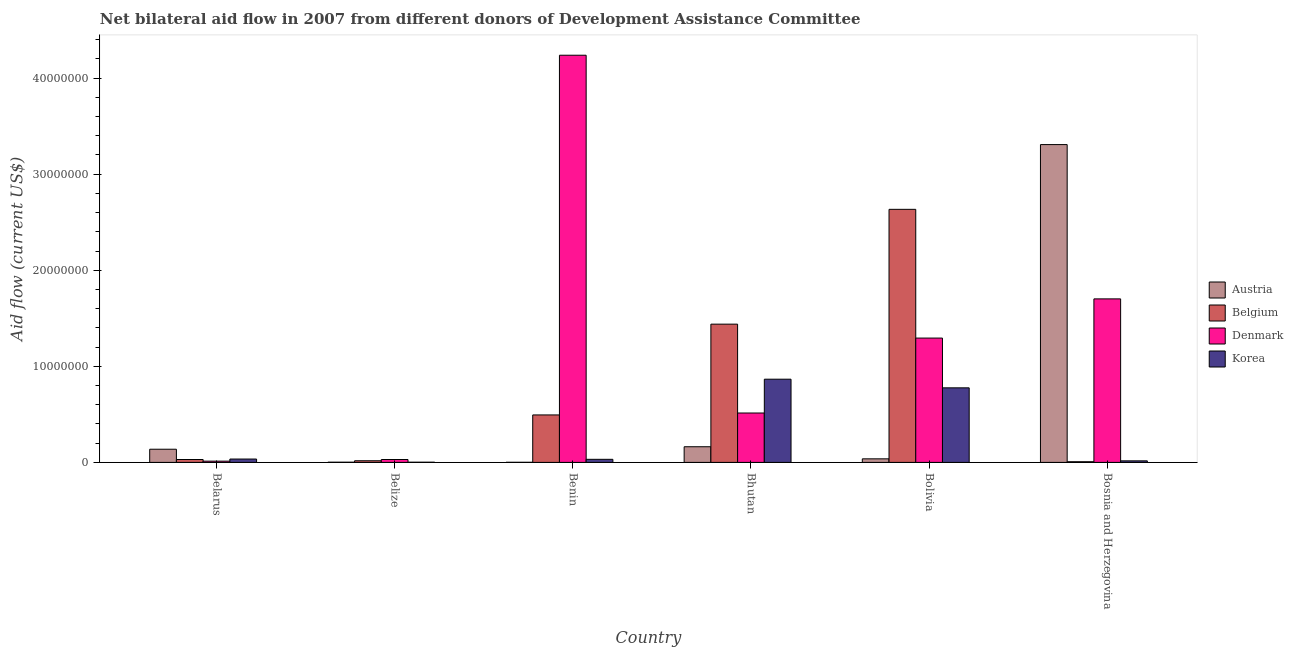How many groups of bars are there?
Give a very brief answer. 6. Are the number of bars per tick equal to the number of legend labels?
Provide a succinct answer. Yes. How many bars are there on the 2nd tick from the right?
Your answer should be compact. 4. What is the label of the 2nd group of bars from the left?
Make the answer very short. Belize. What is the amount of aid given by belgium in Bhutan?
Provide a succinct answer. 1.44e+07. Across all countries, what is the maximum amount of aid given by austria?
Give a very brief answer. 3.31e+07. Across all countries, what is the minimum amount of aid given by korea?
Keep it short and to the point. 2.00e+04. In which country was the amount of aid given by austria maximum?
Offer a terse response. Bosnia and Herzegovina. In which country was the amount of aid given by korea minimum?
Keep it short and to the point. Belize. What is the total amount of aid given by denmark in the graph?
Provide a succinct answer. 7.79e+07. What is the difference between the amount of aid given by denmark in Belarus and that in Bosnia and Herzegovina?
Offer a very short reply. -1.69e+07. What is the difference between the amount of aid given by korea in Bolivia and the amount of aid given by denmark in Belize?
Offer a very short reply. 7.46e+06. What is the average amount of aid given by denmark per country?
Provide a short and direct response. 1.30e+07. What is the difference between the amount of aid given by belgium and amount of aid given by denmark in Belize?
Provide a succinct answer. -1.30e+05. In how many countries, is the amount of aid given by denmark greater than 34000000 US$?
Offer a terse response. 1. What is the ratio of the amount of aid given by austria in Belarus to that in Benin?
Offer a terse response. 137. Is the amount of aid given by denmark in Bhutan less than that in Bolivia?
Your answer should be compact. Yes. Is the difference between the amount of aid given by korea in Belarus and Belize greater than the difference between the amount of aid given by denmark in Belarus and Belize?
Keep it short and to the point. Yes. What is the difference between the highest and the second highest amount of aid given by korea?
Offer a very short reply. 9.00e+05. What is the difference between the highest and the lowest amount of aid given by korea?
Offer a very short reply. 8.64e+06. What does the 2nd bar from the left in Belarus represents?
Make the answer very short. Belgium. What does the 1st bar from the right in Bolivia represents?
Your answer should be compact. Korea. Is it the case that in every country, the sum of the amount of aid given by austria and amount of aid given by belgium is greater than the amount of aid given by denmark?
Provide a short and direct response. No. How many bars are there?
Keep it short and to the point. 24. Are all the bars in the graph horizontal?
Offer a terse response. No. Does the graph contain grids?
Offer a very short reply. No. How many legend labels are there?
Make the answer very short. 4. What is the title of the graph?
Provide a short and direct response. Net bilateral aid flow in 2007 from different donors of Development Assistance Committee. Does "Payroll services" appear as one of the legend labels in the graph?
Make the answer very short. No. What is the label or title of the X-axis?
Make the answer very short. Country. What is the Aid flow (current US$) in Austria in Belarus?
Give a very brief answer. 1.37e+06. What is the Aid flow (current US$) of Belgium in Belarus?
Your answer should be very brief. 3.00e+05. What is the Aid flow (current US$) in Korea in Belarus?
Your answer should be compact. 3.50e+05. What is the Aid flow (current US$) of Austria in Belize?
Your answer should be compact. 2.00e+04. What is the Aid flow (current US$) of Belgium in Belize?
Your response must be concise. 1.70e+05. What is the Aid flow (current US$) in Korea in Belize?
Your answer should be compact. 2.00e+04. What is the Aid flow (current US$) in Austria in Benin?
Provide a succinct answer. 10000. What is the Aid flow (current US$) of Belgium in Benin?
Provide a succinct answer. 4.94e+06. What is the Aid flow (current US$) in Denmark in Benin?
Your answer should be compact. 4.24e+07. What is the Aid flow (current US$) in Korea in Benin?
Your answer should be compact. 3.20e+05. What is the Aid flow (current US$) of Austria in Bhutan?
Give a very brief answer. 1.63e+06. What is the Aid flow (current US$) of Belgium in Bhutan?
Make the answer very short. 1.44e+07. What is the Aid flow (current US$) in Denmark in Bhutan?
Give a very brief answer. 5.14e+06. What is the Aid flow (current US$) in Korea in Bhutan?
Provide a short and direct response. 8.66e+06. What is the Aid flow (current US$) of Belgium in Bolivia?
Your response must be concise. 2.63e+07. What is the Aid flow (current US$) in Denmark in Bolivia?
Your response must be concise. 1.29e+07. What is the Aid flow (current US$) of Korea in Bolivia?
Provide a succinct answer. 7.76e+06. What is the Aid flow (current US$) of Austria in Bosnia and Herzegovina?
Offer a very short reply. 3.31e+07. What is the Aid flow (current US$) of Denmark in Bosnia and Herzegovina?
Keep it short and to the point. 1.70e+07. What is the Aid flow (current US$) of Korea in Bosnia and Herzegovina?
Ensure brevity in your answer.  1.60e+05. Across all countries, what is the maximum Aid flow (current US$) in Austria?
Make the answer very short. 3.31e+07. Across all countries, what is the maximum Aid flow (current US$) in Belgium?
Provide a succinct answer. 2.63e+07. Across all countries, what is the maximum Aid flow (current US$) in Denmark?
Your answer should be very brief. 4.24e+07. Across all countries, what is the maximum Aid flow (current US$) of Korea?
Offer a very short reply. 8.66e+06. Across all countries, what is the minimum Aid flow (current US$) in Korea?
Your answer should be very brief. 2.00e+04. What is the total Aid flow (current US$) in Austria in the graph?
Keep it short and to the point. 3.65e+07. What is the total Aid flow (current US$) of Belgium in the graph?
Give a very brief answer. 4.62e+07. What is the total Aid flow (current US$) of Denmark in the graph?
Provide a succinct answer. 7.79e+07. What is the total Aid flow (current US$) of Korea in the graph?
Make the answer very short. 1.73e+07. What is the difference between the Aid flow (current US$) of Austria in Belarus and that in Belize?
Your answer should be very brief. 1.35e+06. What is the difference between the Aid flow (current US$) of Korea in Belarus and that in Belize?
Ensure brevity in your answer.  3.30e+05. What is the difference between the Aid flow (current US$) in Austria in Belarus and that in Benin?
Make the answer very short. 1.36e+06. What is the difference between the Aid flow (current US$) of Belgium in Belarus and that in Benin?
Your response must be concise. -4.64e+06. What is the difference between the Aid flow (current US$) of Denmark in Belarus and that in Benin?
Offer a terse response. -4.22e+07. What is the difference between the Aid flow (current US$) in Austria in Belarus and that in Bhutan?
Offer a terse response. -2.60e+05. What is the difference between the Aid flow (current US$) of Belgium in Belarus and that in Bhutan?
Ensure brevity in your answer.  -1.41e+07. What is the difference between the Aid flow (current US$) of Denmark in Belarus and that in Bhutan?
Offer a very short reply. -5.01e+06. What is the difference between the Aid flow (current US$) in Korea in Belarus and that in Bhutan?
Ensure brevity in your answer.  -8.31e+06. What is the difference between the Aid flow (current US$) in Austria in Belarus and that in Bolivia?
Your response must be concise. 1.00e+06. What is the difference between the Aid flow (current US$) of Belgium in Belarus and that in Bolivia?
Provide a succinct answer. -2.60e+07. What is the difference between the Aid flow (current US$) in Denmark in Belarus and that in Bolivia?
Your answer should be very brief. -1.28e+07. What is the difference between the Aid flow (current US$) in Korea in Belarus and that in Bolivia?
Provide a short and direct response. -7.41e+06. What is the difference between the Aid flow (current US$) of Austria in Belarus and that in Bosnia and Herzegovina?
Keep it short and to the point. -3.17e+07. What is the difference between the Aid flow (current US$) of Denmark in Belarus and that in Bosnia and Herzegovina?
Make the answer very short. -1.69e+07. What is the difference between the Aid flow (current US$) in Korea in Belarus and that in Bosnia and Herzegovina?
Your answer should be very brief. 1.90e+05. What is the difference between the Aid flow (current US$) of Austria in Belize and that in Benin?
Make the answer very short. 10000. What is the difference between the Aid flow (current US$) in Belgium in Belize and that in Benin?
Your response must be concise. -4.77e+06. What is the difference between the Aid flow (current US$) of Denmark in Belize and that in Benin?
Your response must be concise. -4.21e+07. What is the difference between the Aid flow (current US$) of Korea in Belize and that in Benin?
Make the answer very short. -3.00e+05. What is the difference between the Aid flow (current US$) in Austria in Belize and that in Bhutan?
Your answer should be very brief. -1.61e+06. What is the difference between the Aid flow (current US$) of Belgium in Belize and that in Bhutan?
Your answer should be very brief. -1.42e+07. What is the difference between the Aid flow (current US$) in Denmark in Belize and that in Bhutan?
Offer a very short reply. -4.84e+06. What is the difference between the Aid flow (current US$) of Korea in Belize and that in Bhutan?
Your answer should be compact. -8.64e+06. What is the difference between the Aid flow (current US$) in Austria in Belize and that in Bolivia?
Give a very brief answer. -3.50e+05. What is the difference between the Aid flow (current US$) in Belgium in Belize and that in Bolivia?
Your answer should be compact. -2.62e+07. What is the difference between the Aid flow (current US$) in Denmark in Belize and that in Bolivia?
Make the answer very short. -1.26e+07. What is the difference between the Aid flow (current US$) in Korea in Belize and that in Bolivia?
Keep it short and to the point. -7.74e+06. What is the difference between the Aid flow (current US$) of Austria in Belize and that in Bosnia and Herzegovina?
Give a very brief answer. -3.31e+07. What is the difference between the Aid flow (current US$) of Denmark in Belize and that in Bosnia and Herzegovina?
Your answer should be very brief. -1.67e+07. What is the difference between the Aid flow (current US$) of Austria in Benin and that in Bhutan?
Give a very brief answer. -1.62e+06. What is the difference between the Aid flow (current US$) in Belgium in Benin and that in Bhutan?
Provide a succinct answer. -9.45e+06. What is the difference between the Aid flow (current US$) of Denmark in Benin and that in Bhutan?
Make the answer very short. 3.72e+07. What is the difference between the Aid flow (current US$) in Korea in Benin and that in Bhutan?
Provide a succinct answer. -8.34e+06. What is the difference between the Aid flow (current US$) of Austria in Benin and that in Bolivia?
Keep it short and to the point. -3.60e+05. What is the difference between the Aid flow (current US$) in Belgium in Benin and that in Bolivia?
Provide a succinct answer. -2.14e+07. What is the difference between the Aid flow (current US$) of Denmark in Benin and that in Bolivia?
Your response must be concise. 2.94e+07. What is the difference between the Aid flow (current US$) in Korea in Benin and that in Bolivia?
Your answer should be compact. -7.44e+06. What is the difference between the Aid flow (current US$) of Austria in Benin and that in Bosnia and Herzegovina?
Give a very brief answer. -3.31e+07. What is the difference between the Aid flow (current US$) of Belgium in Benin and that in Bosnia and Herzegovina?
Keep it short and to the point. 4.87e+06. What is the difference between the Aid flow (current US$) in Denmark in Benin and that in Bosnia and Herzegovina?
Give a very brief answer. 2.54e+07. What is the difference between the Aid flow (current US$) in Austria in Bhutan and that in Bolivia?
Ensure brevity in your answer.  1.26e+06. What is the difference between the Aid flow (current US$) in Belgium in Bhutan and that in Bolivia?
Provide a short and direct response. -1.20e+07. What is the difference between the Aid flow (current US$) of Denmark in Bhutan and that in Bolivia?
Offer a terse response. -7.80e+06. What is the difference between the Aid flow (current US$) of Austria in Bhutan and that in Bosnia and Herzegovina?
Your response must be concise. -3.14e+07. What is the difference between the Aid flow (current US$) of Belgium in Bhutan and that in Bosnia and Herzegovina?
Your response must be concise. 1.43e+07. What is the difference between the Aid flow (current US$) of Denmark in Bhutan and that in Bosnia and Herzegovina?
Provide a succinct answer. -1.19e+07. What is the difference between the Aid flow (current US$) of Korea in Bhutan and that in Bosnia and Herzegovina?
Your answer should be compact. 8.50e+06. What is the difference between the Aid flow (current US$) of Austria in Bolivia and that in Bosnia and Herzegovina?
Offer a terse response. -3.27e+07. What is the difference between the Aid flow (current US$) of Belgium in Bolivia and that in Bosnia and Herzegovina?
Offer a terse response. 2.63e+07. What is the difference between the Aid flow (current US$) in Denmark in Bolivia and that in Bosnia and Herzegovina?
Your answer should be compact. -4.08e+06. What is the difference between the Aid flow (current US$) of Korea in Bolivia and that in Bosnia and Herzegovina?
Provide a succinct answer. 7.60e+06. What is the difference between the Aid flow (current US$) of Austria in Belarus and the Aid flow (current US$) of Belgium in Belize?
Ensure brevity in your answer.  1.20e+06. What is the difference between the Aid flow (current US$) in Austria in Belarus and the Aid flow (current US$) in Denmark in Belize?
Ensure brevity in your answer.  1.07e+06. What is the difference between the Aid flow (current US$) in Austria in Belarus and the Aid flow (current US$) in Korea in Belize?
Keep it short and to the point. 1.35e+06. What is the difference between the Aid flow (current US$) of Belgium in Belarus and the Aid flow (current US$) of Denmark in Belize?
Your response must be concise. 0. What is the difference between the Aid flow (current US$) in Belgium in Belarus and the Aid flow (current US$) in Korea in Belize?
Offer a terse response. 2.80e+05. What is the difference between the Aid flow (current US$) of Austria in Belarus and the Aid flow (current US$) of Belgium in Benin?
Your answer should be compact. -3.57e+06. What is the difference between the Aid flow (current US$) of Austria in Belarus and the Aid flow (current US$) of Denmark in Benin?
Ensure brevity in your answer.  -4.10e+07. What is the difference between the Aid flow (current US$) of Austria in Belarus and the Aid flow (current US$) of Korea in Benin?
Give a very brief answer. 1.05e+06. What is the difference between the Aid flow (current US$) of Belgium in Belarus and the Aid flow (current US$) of Denmark in Benin?
Ensure brevity in your answer.  -4.21e+07. What is the difference between the Aid flow (current US$) of Belgium in Belarus and the Aid flow (current US$) of Korea in Benin?
Keep it short and to the point. -2.00e+04. What is the difference between the Aid flow (current US$) in Austria in Belarus and the Aid flow (current US$) in Belgium in Bhutan?
Provide a succinct answer. -1.30e+07. What is the difference between the Aid flow (current US$) of Austria in Belarus and the Aid flow (current US$) of Denmark in Bhutan?
Offer a terse response. -3.77e+06. What is the difference between the Aid flow (current US$) in Austria in Belarus and the Aid flow (current US$) in Korea in Bhutan?
Make the answer very short. -7.29e+06. What is the difference between the Aid flow (current US$) in Belgium in Belarus and the Aid flow (current US$) in Denmark in Bhutan?
Offer a terse response. -4.84e+06. What is the difference between the Aid flow (current US$) in Belgium in Belarus and the Aid flow (current US$) in Korea in Bhutan?
Make the answer very short. -8.36e+06. What is the difference between the Aid flow (current US$) in Denmark in Belarus and the Aid flow (current US$) in Korea in Bhutan?
Keep it short and to the point. -8.53e+06. What is the difference between the Aid flow (current US$) in Austria in Belarus and the Aid flow (current US$) in Belgium in Bolivia?
Keep it short and to the point. -2.50e+07. What is the difference between the Aid flow (current US$) of Austria in Belarus and the Aid flow (current US$) of Denmark in Bolivia?
Provide a succinct answer. -1.16e+07. What is the difference between the Aid flow (current US$) in Austria in Belarus and the Aid flow (current US$) in Korea in Bolivia?
Provide a short and direct response. -6.39e+06. What is the difference between the Aid flow (current US$) in Belgium in Belarus and the Aid flow (current US$) in Denmark in Bolivia?
Provide a short and direct response. -1.26e+07. What is the difference between the Aid flow (current US$) in Belgium in Belarus and the Aid flow (current US$) in Korea in Bolivia?
Offer a very short reply. -7.46e+06. What is the difference between the Aid flow (current US$) in Denmark in Belarus and the Aid flow (current US$) in Korea in Bolivia?
Keep it short and to the point. -7.63e+06. What is the difference between the Aid flow (current US$) in Austria in Belarus and the Aid flow (current US$) in Belgium in Bosnia and Herzegovina?
Provide a short and direct response. 1.30e+06. What is the difference between the Aid flow (current US$) in Austria in Belarus and the Aid flow (current US$) in Denmark in Bosnia and Herzegovina?
Provide a short and direct response. -1.56e+07. What is the difference between the Aid flow (current US$) of Austria in Belarus and the Aid flow (current US$) of Korea in Bosnia and Herzegovina?
Provide a succinct answer. 1.21e+06. What is the difference between the Aid flow (current US$) of Belgium in Belarus and the Aid flow (current US$) of Denmark in Bosnia and Herzegovina?
Provide a succinct answer. -1.67e+07. What is the difference between the Aid flow (current US$) of Belgium in Belarus and the Aid flow (current US$) of Korea in Bosnia and Herzegovina?
Provide a succinct answer. 1.40e+05. What is the difference between the Aid flow (current US$) of Denmark in Belarus and the Aid flow (current US$) of Korea in Bosnia and Herzegovina?
Offer a terse response. -3.00e+04. What is the difference between the Aid flow (current US$) in Austria in Belize and the Aid flow (current US$) in Belgium in Benin?
Offer a very short reply. -4.92e+06. What is the difference between the Aid flow (current US$) in Austria in Belize and the Aid flow (current US$) in Denmark in Benin?
Your response must be concise. -4.24e+07. What is the difference between the Aid flow (current US$) in Belgium in Belize and the Aid flow (current US$) in Denmark in Benin?
Make the answer very short. -4.22e+07. What is the difference between the Aid flow (current US$) of Belgium in Belize and the Aid flow (current US$) of Korea in Benin?
Ensure brevity in your answer.  -1.50e+05. What is the difference between the Aid flow (current US$) in Austria in Belize and the Aid flow (current US$) in Belgium in Bhutan?
Ensure brevity in your answer.  -1.44e+07. What is the difference between the Aid flow (current US$) of Austria in Belize and the Aid flow (current US$) of Denmark in Bhutan?
Your answer should be compact. -5.12e+06. What is the difference between the Aid flow (current US$) of Austria in Belize and the Aid flow (current US$) of Korea in Bhutan?
Give a very brief answer. -8.64e+06. What is the difference between the Aid flow (current US$) in Belgium in Belize and the Aid flow (current US$) in Denmark in Bhutan?
Your response must be concise. -4.97e+06. What is the difference between the Aid flow (current US$) in Belgium in Belize and the Aid flow (current US$) in Korea in Bhutan?
Your response must be concise. -8.49e+06. What is the difference between the Aid flow (current US$) in Denmark in Belize and the Aid flow (current US$) in Korea in Bhutan?
Give a very brief answer. -8.36e+06. What is the difference between the Aid flow (current US$) of Austria in Belize and the Aid flow (current US$) of Belgium in Bolivia?
Make the answer very short. -2.63e+07. What is the difference between the Aid flow (current US$) of Austria in Belize and the Aid flow (current US$) of Denmark in Bolivia?
Ensure brevity in your answer.  -1.29e+07. What is the difference between the Aid flow (current US$) in Austria in Belize and the Aid flow (current US$) in Korea in Bolivia?
Ensure brevity in your answer.  -7.74e+06. What is the difference between the Aid flow (current US$) in Belgium in Belize and the Aid flow (current US$) in Denmark in Bolivia?
Offer a very short reply. -1.28e+07. What is the difference between the Aid flow (current US$) in Belgium in Belize and the Aid flow (current US$) in Korea in Bolivia?
Make the answer very short. -7.59e+06. What is the difference between the Aid flow (current US$) of Denmark in Belize and the Aid flow (current US$) of Korea in Bolivia?
Make the answer very short. -7.46e+06. What is the difference between the Aid flow (current US$) in Austria in Belize and the Aid flow (current US$) in Belgium in Bosnia and Herzegovina?
Provide a succinct answer. -5.00e+04. What is the difference between the Aid flow (current US$) of Austria in Belize and the Aid flow (current US$) of Denmark in Bosnia and Herzegovina?
Your response must be concise. -1.70e+07. What is the difference between the Aid flow (current US$) in Belgium in Belize and the Aid flow (current US$) in Denmark in Bosnia and Herzegovina?
Your answer should be compact. -1.68e+07. What is the difference between the Aid flow (current US$) in Denmark in Belize and the Aid flow (current US$) in Korea in Bosnia and Herzegovina?
Keep it short and to the point. 1.40e+05. What is the difference between the Aid flow (current US$) of Austria in Benin and the Aid flow (current US$) of Belgium in Bhutan?
Ensure brevity in your answer.  -1.44e+07. What is the difference between the Aid flow (current US$) of Austria in Benin and the Aid flow (current US$) of Denmark in Bhutan?
Keep it short and to the point. -5.13e+06. What is the difference between the Aid flow (current US$) of Austria in Benin and the Aid flow (current US$) of Korea in Bhutan?
Your answer should be compact. -8.65e+06. What is the difference between the Aid flow (current US$) in Belgium in Benin and the Aid flow (current US$) in Denmark in Bhutan?
Your answer should be very brief. -2.00e+05. What is the difference between the Aid flow (current US$) in Belgium in Benin and the Aid flow (current US$) in Korea in Bhutan?
Your answer should be compact. -3.72e+06. What is the difference between the Aid flow (current US$) of Denmark in Benin and the Aid flow (current US$) of Korea in Bhutan?
Your answer should be compact. 3.37e+07. What is the difference between the Aid flow (current US$) in Austria in Benin and the Aid flow (current US$) in Belgium in Bolivia?
Offer a very short reply. -2.63e+07. What is the difference between the Aid flow (current US$) in Austria in Benin and the Aid flow (current US$) in Denmark in Bolivia?
Offer a very short reply. -1.29e+07. What is the difference between the Aid flow (current US$) of Austria in Benin and the Aid flow (current US$) of Korea in Bolivia?
Ensure brevity in your answer.  -7.75e+06. What is the difference between the Aid flow (current US$) of Belgium in Benin and the Aid flow (current US$) of Denmark in Bolivia?
Offer a very short reply. -8.00e+06. What is the difference between the Aid flow (current US$) in Belgium in Benin and the Aid flow (current US$) in Korea in Bolivia?
Your answer should be very brief. -2.82e+06. What is the difference between the Aid flow (current US$) in Denmark in Benin and the Aid flow (current US$) in Korea in Bolivia?
Give a very brief answer. 3.46e+07. What is the difference between the Aid flow (current US$) of Austria in Benin and the Aid flow (current US$) of Belgium in Bosnia and Herzegovina?
Keep it short and to the point. -6.00e+04. What is the difference between the Aid flow (current US$) in Austria in Benin and the Aid flow (current US$) in Denmark in Bosnia and Herzegovina?
Your answer should be compact. -1.70e+07. What is the difference between the Aid flow (current US$) in Austria in Benin and the Aid flow (current US$) in Korea in Bosnia and Herzegovina?
Give a very brief answer. -1.50e+05. What is the difference between the Aid flow (current US$) of Belgium in Benin and the Aid flow (current US$) of Denmark in Bosnia and Herzegovina?
Give a very brief answer. -1.21e+07. What is the difference between the Aid flow (current US$) of Belgium in Benin and the Aid flow (current US$) of Korea in Bosnia and Herzegovina?
Your answer should be very brief. 4.78e+06. What is the difference between the Aid flow (current US$) of Denmark in Benin and the Aid flow (current US$) of Korea in Bosnia and Herzegovina?
Make the answer very short. 4.22e+07. What is the difference between the Aid flow (current US$) in Austria in Bhutan and the Aid flow (current US$) in Belgium in Bolivia?
Provide a succinct answer. -2.47e+07. What is the difference between the Aid flow (current US$) in Austria in Bhutan and the Aid flow (current US$) in Denmark in Bolivia?
Your answer should be very brief. -1.13e+07. What is the difference between the Aid flow (current US$) of Austria in Bhutan and the Aid flow (current US$) of Korea in Bolivia?
Ensure brevity in your answer.  -6.13e+06. What is the difference between the Aid flow (current US$) in Belgium in Bhutan and the Aid flow (current US$) in Denmark in Bolivia?
Offer a very short reply. 1.45e+06. What is the difference between the Aid flow (current US$) of Belgium in Bhutan and the Aid flow (current US$) of Korea in Bolivia?
Give a very brief answer. 6.63e+06. What is the difference between the Aid flow (current US$) of Denmark in Bhutan and the Aid flow (current US$) of Korea in Bolivia?
Offer a terse response. -2.62e+06. What is the difference between the Aid flow (current US$) in Austria in Bhutan and the Aid flow (current US$) in Belgium in Bosnia and Herzegovina?
Provide a succinct answer. 1.56e+06. What is the difference between the Aid flow (current US$) of Austria in Bhutan and the Aid flow (current US$) of Denmark in Bosnia and Herzegovina?
Provide a short and direct response. -1.54e+07. What is the difference between the Aid flow (current US$) in Austria in Bhutan and the Aid flow (current US$) in Korea in Bosnia and Herzegovina?
Offer a very short reply. 1.47e+06. What is the difference between the Aid flow (current US$) in Belgium in Bhutan and the Aid flow (current US$) in Denmark in Bosnia and Herzegovina?
Give a very brief answer. -2.63e+06. What is the difference between the Aid flow (current US$) in Belgium in Bhutan and the Aid flow (current US$) in Korea in Bosnia and Herzegovina?
Provide a succinct answer. 1.42e+07. What is the difference between the Aid flow (current US$) of Denmark in Bhutan and the Aid flow (current US$) of Korea in Bosnia and Herzegovina?
Offer a very short reply. 4.98e+06. What is the difference between the Aid flow (current US$) of Austria in Bolivia and the Aid flow (current US$) of Belgium in Bosnia and Herzegovina?
Your answer should be very brief. 3.00e+05. What is the difference between the Aid flow (current US$) in Austria in Bolivia and the Aid flow (current US$) in Denmark in Bosnia and Herzegovina?
Provide a short and direct response. -1.66e+07. What is the difference between the Aid flow (current US$) in Belgium in Bolivia and the Aid flow (current US$) in Denmark in Bosnia and Herzegovina?
Provide a succinct answer. 9.32e+06. What is the difference between the Aid flow (current US$) of Belgium in Bolivia and the Aid flow (current US$) of Korea in Bosnia and Herzegovina?
Make the answer very short. 2.62e+07. What is the difference between the Aid flow (current US$) in Denmark in Bolivia and the Aid flow (current US$) in Korea in Bosnia and Herzegovina?
Keep it short and to the point. 1.28e+07. What is the average Aid flow (current US$) in Austria per country?
Give a very brief answer. 6.08e+06. What is the average Aid flow (current US$) of Belgium per country?
Your answer should be compact. 7.70e+06. What is the average Aid flow (current US$) in Denmark per country?
Provide a short and direct response. 1.30e+07. What is the average Aid flow (current US$) in Korea per country?
Provide a succinct answer. 2.88e+06. What is the difference between the Aid flow (current US$) in Austria and Aid flow (current US$) in Belgium in Belarus?
Give a very brief answer. 1.07e+06. What is the difference between the Aid flow (current US$) of Austria and Aid flow (current US$) of Denmark in Belarus?
Provide a succinct answer. 1.24e+06. What is the difference between the Aid flow (current US$) in Austria and Aid flow (current US$) in Korea in Belarus?
Give a very brief answer. 1.02e+06. What is the difference between the Aid flow (current US$) of Belgium and Aid flow (current US$) of Denmark in Belarus?
Keep it short and to the point. 1.70e+05. What is the difference between the Aid flow (current US$) of Austria and Aid flow (current US$) of Belgium in Belize?
Offer a terse response. -1.50e+05. What is the difference between the Aid flow (current US$) of Austria and Aid flow (current US$) of Denmark in Belize?
Provide a short and direct response. -2.80e+05. What is the difference between the Aid flow (current US$) of Austria and Aid flow (current US$) of Korea in Belize?
Provide a succinct answer. 0. What is the difference between the Aid flow (current US$) in Belgium and Aid flow (current US$) in Denmark in Belize?
Offer a very short reply. -1.30e+05. What is the difference between the Aid flow (current US$) of Belgium and Aid flow (current US$) of Korea in Belize?
Offer a terse response. 1.50e+05. What is the difference between the Aid flow (current US$) of Austria and Aid flow (current US$) of Belgium in Benin?
Your response must be concise. -4.93e+06. What is the difference between the Aid flow (current US$) of Austria and Aid flow (current US$) of Denmark in Benin?
Give a very brief answer. -4.24e+07. What is the difference between the Aid flow (current US$) in Austria and Aid flow (current US$) in Korea in Benin?
Your answer should be very brief. -3.10e+05. What is the difference between the Aid flow (current US$) of Belgium and Aid flow (current US$) of Denmark in Benin?
Make the answer very short. -3.74e+07. What is the difference between the Aid flow (current US$) of Belgium and Aid flow (current US$) of Korea in Benin?
Provide a short and direct response. 4.62e+06. What is the difference between the Aid flow (current US$) of Denmark and Aid flow (current US$) of Korea in Benin?
Offer a very short reply. 4.21e+07. What is the difference between the Aid flow (current US$) of Austria and Aid flow (current US$) of Belgium in Bhutan?
Your answer should be very brief. -1.28e+07. What is the difference between the Aid flow (current US$) in Austria and Aid flow (current US$) in Denmark in Bhutan?
Keep it short and to the point. -3.51e+06. What is the difference between the Aid flow (current US$) of Austria and Aid flow (current US$) of Korea in Bhutan?
Offer a terse response. -7.03e+06. What is the difference between the Aid flow (current US$) in Belgium and Aid flow (current US$) in Denmark in Bhutan?
Make the answer very short. 9.25e+06. What is the difference between the Aid flow (current US$) in Belgium and Aid flow (current US$) in Korea in Bhutan?
Keep it short and to the point. 5.73e+06. What is the difference between the Aid flow (current US$) of Denmark and Aid flow (current US$) of Korea in Bhutan?
Offer a terse response. -3.52e+06. What is the difference between the Aid flow (current US$) of Austria and Aid flow (current US$) of Belgium in Bolivia?
Keep it short and to the point. -2.60e+07. What is the difference between the Aid flow (current US$) of Austria and Aid flow (current US$) of Denmark in Bolivia?
Provide a succinct answer. -1.26e+07. What is the difference between the Aid flow (current US$) in Austria and Aid flow (current US$) in Korea in Bolivia?
Provide a short and direct response. -7.39e+06. What is the difference between the Aid flow (current US$) of Belgium and Aid flow (current US$) of Denmark in Bolivia?
Give a very brief answer. 1.34e+07. What is the difference between the Aid flow (current US$) of Belgium and Aid flow (current US$) of Korea in Bolivia?
Offer a terse response. 1.86e+07. What is the difference between the Aid flow (current US$) of Denmark and Aid flow (current US$) of Korea in Bolivia?
Keep it short and to the point. 5.18e+06. What is the difference between the Aid flow (current US$) of Austria and Aid flow (current US$) of Belgium in Bosnia and Herzegovina?
Provide a short and direct response. 3.30e+07. What is the difference between the Aid flow (current US$) of Austria and Aid flow (current US$) of Denmark in Bosnia and Herzegovina?
Keep it short and to the point. 1.61e+07. What is the difference between the Aid flow (current US$) in Austria and Aid flow (current US$) in Korea in Bosnia and Herzegovina?
Offer a terse response. 3.29e+07. What is the difference between the Aid flow (current US$) in Belgium and Aid flow (current US$) in Denmark in Bosnia and Herzegovina?
Ensure brevity in your answer.  -1.70e+07. What is the difference between the Aid flow (current US$) in Denmark and Aid flow (current US$) in Korea in Bosnia and Herzegovina?
Offer a very short reply. 1.69e+07. What is the ratio of the Aid flow (current US$) of Austria in Belarus to that in Belize?
Offer a very short reply. 68.5. What is the ratio of the Aid flow (current US$) of Belgium in Belarus to that in Belize?
Provide a short and direct response. 1.76. What is the ratio of the Aid flow (current US$) of Denmark in Belarus to that in Belize?
Provide a succinct answer. 0.43. What is the ratio of the Aid flow (current US$) of Korea in Belarus to that in Belize?
Offer a terse response. 17.5. What is the ratio of the Aid flow (current US$) in Austria in Belarus to that in Benin?
Ensure brevity in your answer.  137. What is the ratio of the Aid flow (current US$) in Belgium in Belarus to that in Benin?
Give a very brief answer. 0.06. What is the ratio of the Aid flow (current US$) of Denmark in Belarus to that in Benin?
Make the answer very short. 0. What is the ratio of the Aid flow (current US$) of Korea in Belarus to that in Benin?
Give a very brief answer. 1.09. What is the ratio of the Aid flow (current US$) in Austria in Belarus to that in Bhutan?
Give a very brief answer. 0.84. What is the ratio of the Aid flow (current US$) of Belgium in Belarus to that in Bhutan?
Give a very brief answer. 0.02. What is the ratio of the Aid flow (current US$) in Denmark in Belarus to that in Bhutan?
Your response must be concise. 0.03. What is the ratio of the Aid flow (current US$) of Korea in Belarus to that in Bhutan?
Give a very brief answer. 0.04. What is the ratio of the Aid flow (current US$) in Austria in Belarus to that in Bolivia?
Provide a succinct answer. 3.7. What is the ratio of the Aid flow (current US$) of Belgium in Belarus to that in Bolivia?
Provide a short and direct response. 0.01. What is the ratio of the Aid flow (current US$) in Denmark in Belarus to that in Bolivia?
Give a very brief answer. 0.01. What is the ratio of the Aid flow (current US$) of Korea in Belarus to that in Bolivia?
Offer a very short reply. 0.05. What is the ratio of the Aid flow (current US$) of Austria in Belarus to that in Bosnia and Herzegovina?
Ensure brevity in your answer.  0.04. What is the ratio of the Aid flow (current US$) of Belgium in Belarus to that in Bosnia and Herzegovina?
Your answer should be very brief. 4.29. What is the ratio of the Aid flow (current US$) in Denmark in Belarus to that in Bosnia and Herzegovina?
Ensure brevity in your answer.  0.01. What is the ratio of the Aid flow (current US$) of Korea in Belarus to that in Bosnia and Herzegovina?
Your answer should be very brief. 2.19. What is the ratio of the Aid flow (current US$) of Austria in Belize to that in Benin?
Provide a short and direct response. 2. What is the ratio of the Aid flow (current US$) of Belgium in Belize to that in Benin?
Your answer should be very brief. 0.03. What is the ratio of the Aid flow (current US$) of Denmark in Belize to that in Benin?
Offer a very short reply. 0.01. What is the ratio of the Aid flow (current US$) of Korea in Belize to that in Benin?
Provide a succinct answer. 0.06. What is the ratio of the Aid flow (current US$) in Austria in Belize to that in Bhutan?
Provide a succinct answer. 0.01. What is the ratio of the Aid flow (current US$) of Belgium in Belize to that in Bhutan?
Keep it short and to the point. 0.01. What is the ratio of the Aid flow (current US$) of Denmark in Belize to that in Bhutan?
Offer a very short reply. 0.06. What is the ratio of the Aid flow (current US$) in Korea in Belize to that in Bhutan?
Your answer should be very brief. 0. What is the ratio of the Aid flow (current US$) in Austria in Belize to that in Bolivia?
Make the answer very short. 0.05. What is the ratio of the Aid flow (current US$) of Belgium in Belize to that in Bolivia?
Offer a very short reply. 0.01. What is the ratio of the Aid flow (current US$) of Denmark in Belize to that in Bolivia?
Offer a very short reply. 0.02. What is the ratio of the Aid flow (current US$) of Korea in Belize to that in Bolivia?
Provide a succinct answer. 0. What is the ratio of the Aid flow (current US$) of Austria in Belize to that in Bosnia and Herzegovina?
Give a very brief answer. 0. What is the ratio of the Aid flow (current US$) in Belgium in Belize to that in Bosnia and Herzegovina?
Offer a terse response. 2.43. What is the ratio of the Aid flow (current US$) of Denmark in Belize to that in Bosnia and Herzegovina?
Make the answer very short. 0.02. What is the ratio of the Aid flow (current US$) of Korea in Belize to that in Bosnia and Herzegovina?
Your response must be concise. 0.12. What is the ratio of the Aid flow (current US$) in Austria in Benin to that in Bhutan?
Provide a succinct answer. 0.01. What is the ratio of the Aid flow (current US$) in Belgium in Benin to that in Bhutan?
Give a very brief answer. 0.34. What is the ratio of the Aid flow (current US$) in Denmark in Benin to that in Bhutan?
Offer a very short reply. 8.25. What is the ratio of the Aid flow (current US$) of Korea in Benin to that in Bhutan?
Your answer should be very brief. 0.04. What is the ratio of the Aid flow (current US$) of Austria in Benin to that in Bolivia?
Give a very brief answer. 0.03. What is the ratio of the Aid flow (current US$) in Belgium in Benin to that in Bolivia?
Ensure brevity in your answer.  0.19. What is the ratio of the Aid flow (current US$) of Denmark in Benin to that in Bolivia?
Your response must be concise. 3.28. What is the ratio of the Aid flow (current US$) in Korea in Benin to that in Bolivia?
Your answer should be compact. 0.04. What is the ratio of the Aid flow (current US$) of Austria in Benin to that in Bosnia and Herzegovina?
Your answer should be very brief. 0. What is the ratio of the Aid flow (current US$) of Belgium in Benin to that in Bosnia and Herzegovina?
Give a very brief answer. 70.57. What is the ratio of the Aid flow (current US$) in Denmark in Benin to that in Bosnia and Herzegovina?
Ensure brevity in your answer.  2.49. What is the ratio of the Aid flow (current US$) of Korea in Benin to that in Bosnia and Herzegovina?
Offer a terse response. 2. What is the ratio of the Aid flow (current US$) in Austria in Bhutan to that in Bolivia?
Your answer should be very brief. 4.41. What is the ratio of the Aid flow (current US$) in Belgium in Bhutan to that in Bolivia?
Ensure brevity in your answer.  0.55. What is the ratio of the Aid flow (current US$) of Denmark in Bhutan to that in Bolivia?
Your response must be concise. 0.4. What is the ratio of the Aid flow (current US$) of Korea in Bhutan to that in Bolivia?
Ensure brevity in your answer.  1.12. What is the ratio of the Aid flow (current US$) of Austria in Bhutan to that in Bosnia and Herzegovina?
Offer a terse response. 0.05. What is the ratio of the Aid flow (current US$) of Belgium in Bhutan to that in Bosnia and Herzegovina?
Keep it short and to the point. 205.57. What is the ratio of the Aid flow (current US$) in Denmark in Bhutan to that in Bosnia and Herzegovina?
Offer a very short reply. 0.3. What is the ratio of the Aid flow (current US$) in Korea in Bhutan to that in Bosnia and Herzegovina?
Provide a succinct answer. 54.12. What is the ratio of the Aid flow (current US$) of Austria in Bolivia to that in Bosnia and Herzegovina?
Provide a short and direct response. 0.01. What is the ratio of the Aid flow (current US$) in Belgium in Bolivia to that in Bosnia and Herzegovina?
Give a very brief answer. 376.29. What is the ratio of the Aid flow (current US$) in Denmark in Bolivia to that in Bosnia and Herzegovina?
Ensure brevity in your answer.  0.76. What is the ratio of the Aid flow (current US$) of Korea in Bolivia to that in Bosnia and Herzegovina?
Provide a short and direct response. 48.5. What is the difference between the highest and the second highest Aid flow (current US$) in Austria?
Give a very brief answer. 3.14e+07. What is the difference between the highest and the second highest Aid flow (current US$) in Belgium?
Your answer should be compact. 1.20e+07. What is the difference between the highest and the second highest Aid flow (current US$) in Denmark?
Ensure brevity in your answer.  2.54e+07. What is the difference between the highest and the lowest Aid flow (current US$) in Austria?
Your answer should be very brief. 3.31e+07. What is the difference between the highest and the lowest Aid flow (current US$) of Belgium?
Your response must be concise. 2.63e+07. What is the difference between the highest and the lowest Aid flow (current US$) of Denmark?
Provide a short and direct response. 4.22e+07. What is the difference between the highest and the lowest Aid flow (current US$) in Korea?
Provide a succinct answer. 8.64e+06. 